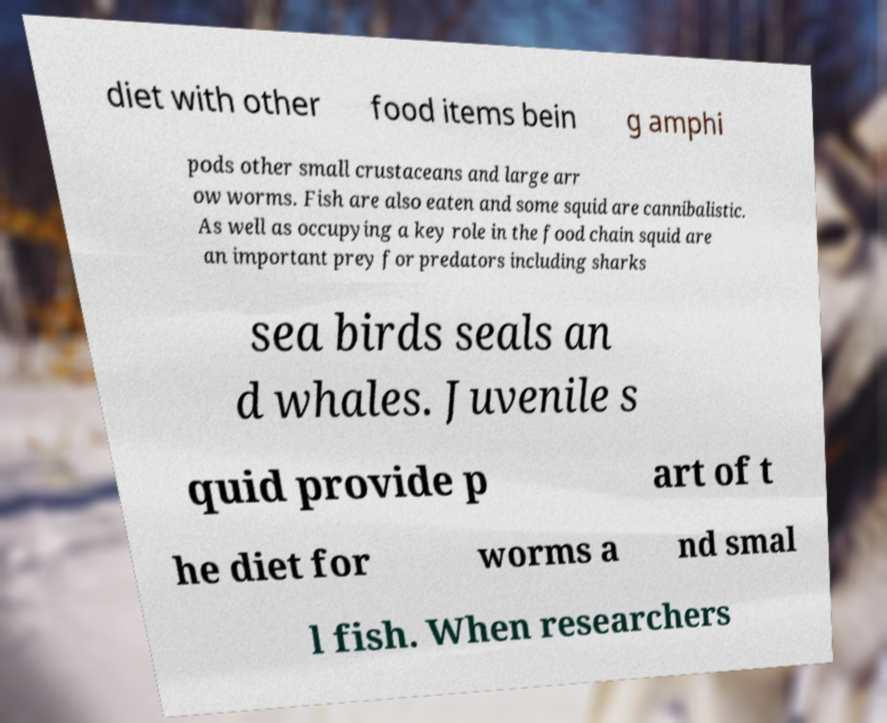What messages or text are displayed in this image? I need them in a readable, typed format. diet with other food items bein g amphi pods other small crustaceans and large arr ow worms. Fish are also eaten and some squid are cannibalistic. As well as occupying a key role in the food chain squid are an important prey for predators including sharks sea birds seals an d whales. Juvenile s quid provide p art of t he diet for worms a nd smal l fish. When researchers 